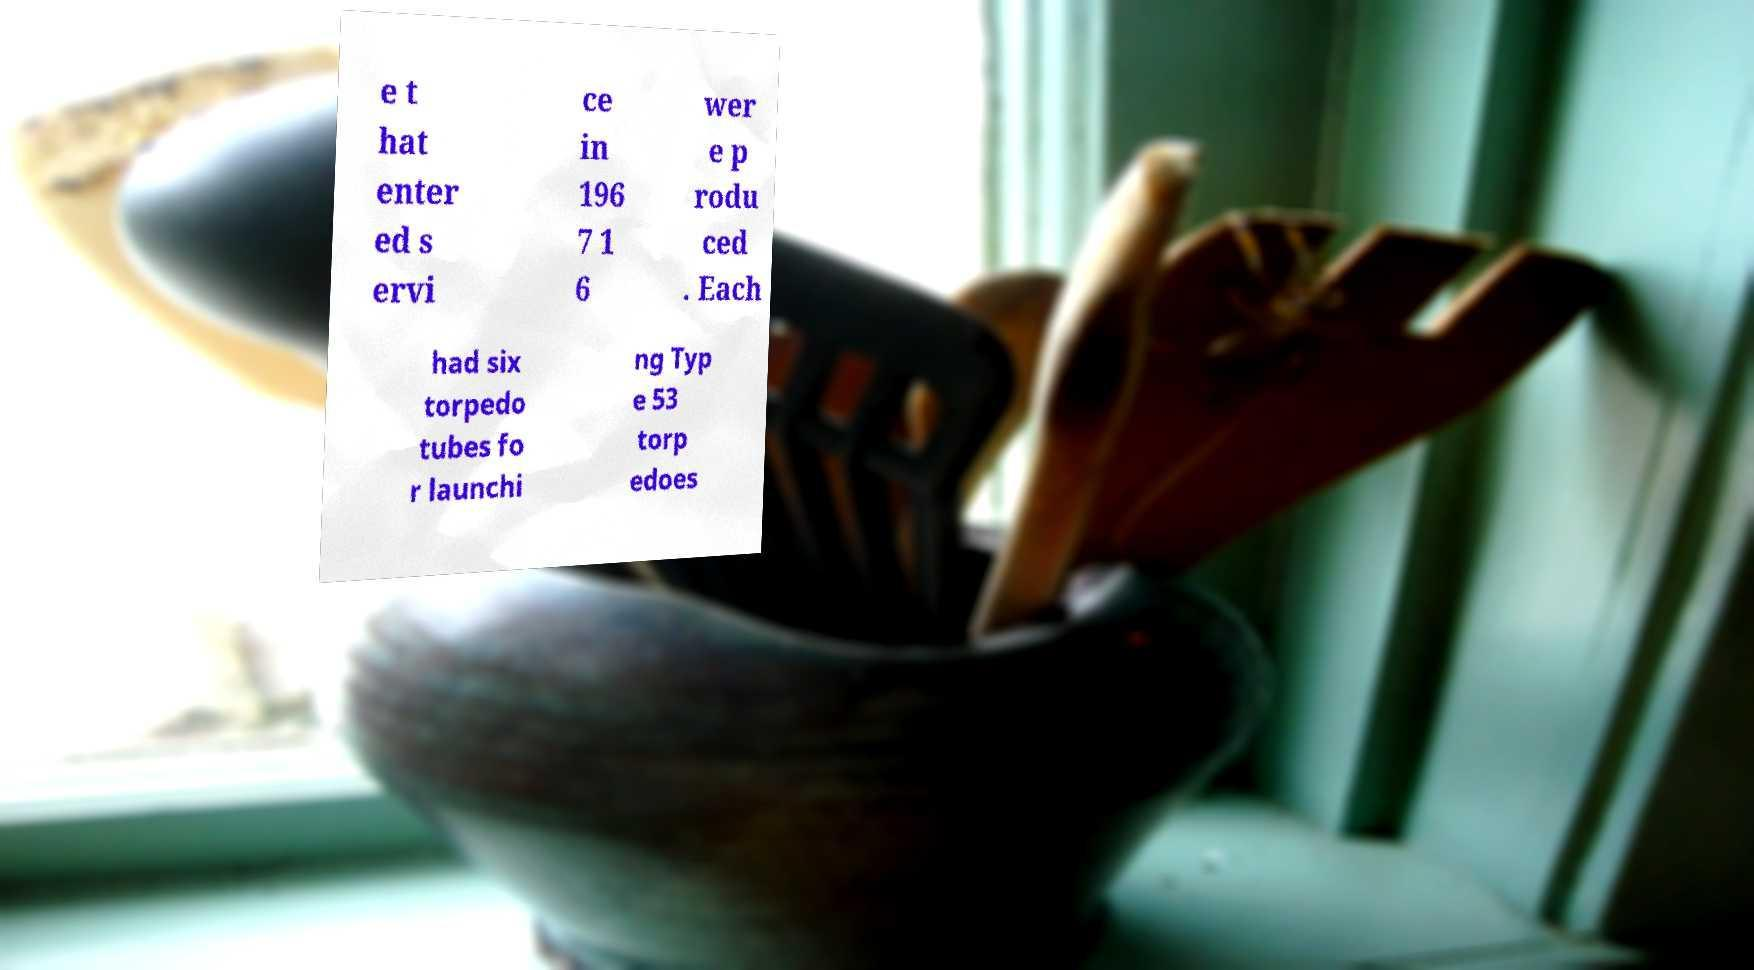Please read and relay the text visible in this image. What does it say? e t hat enter ed s ervi ce in 196 7 1 6 wer e p rodu ced . Each had six torpedo tubes fo r launchi ng Typ e 53 torp edoes 